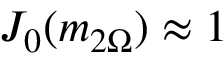<formula> <loc_0><loc_0><loc_500><loc_500>J _ { 0 } ( m _ { 2 \Omega } ) \approx 1</formula> 